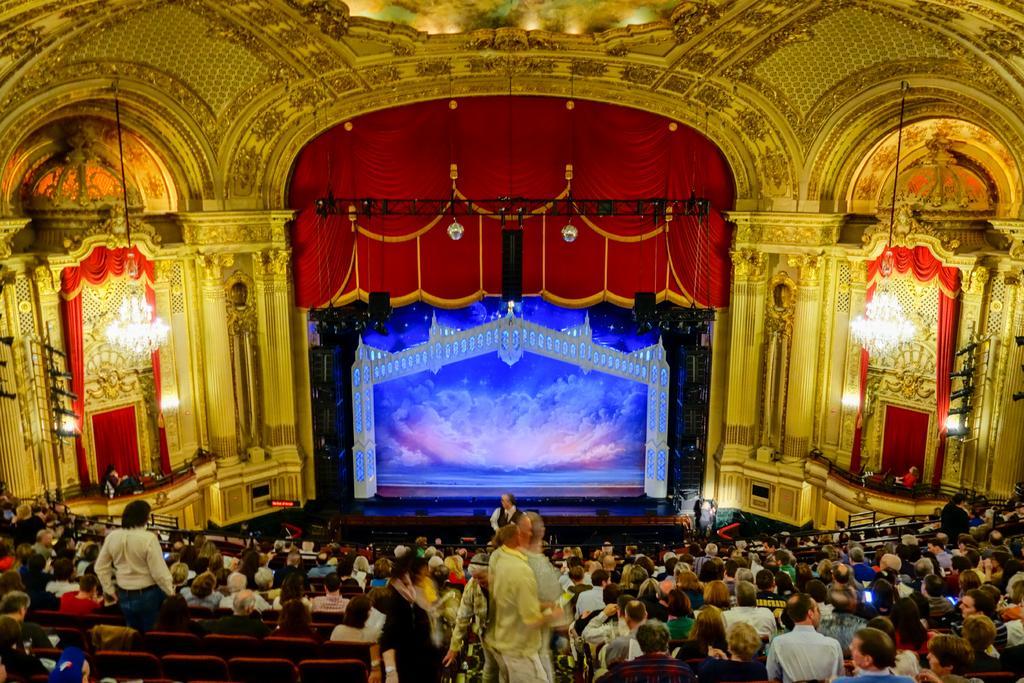In one or two sentences, can you explain what this image depicts? In the foreground of the image we can see a group of people are sitting on the chairs. In the middle of the image we can see a stage, curtain and jhumar. At the top of the image we can see lights and curtains. 